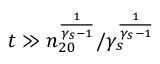<formula> <loc_0><loc_0><loc_500><loc_500>t \gg n _ { 2 0 } ^ { \frac { 1 } { \gamma _ { s } - 1 } } / \gamma _ { s } ^ { \frac { 1 } { \gamma _ { s } - 1 } }</formula> 